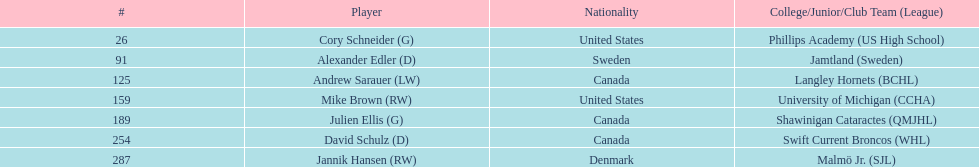Who is the exclusive player with danish nationality? Jannik Hansen (RW). Can you parse all the data within this table? {'header': ['#', 'Player', 'Nationality', 'College/Junior/Club Team (League)'], 'rows': [['26', 'Cory Schneider (G)', 'United States', 'Phillips Academy (US High School)'], ['91', 'Alexander Edler (D)', 'Sweden', 'Jamtland (Sweden)'], ['125', 'Andrew Sarauer (LW)', 'Canada', 'Langley Hornets (BCHL)'], ['159', 'Mike Brown (RW)', 'United States', 'University of Michigan (CCHA)'], ['189', 'Julien Ellis (G)', 'Canada', 'Shawinigan Cataractes (QMJHL)'], ['254', 'David Schulz (D)', 'Canada', 'Swift Current Broncos (WHL)'], ['287', 'Jannik Hansen (RW)', 'Denmark', 'Malmö Jr. (SJL)']]} 